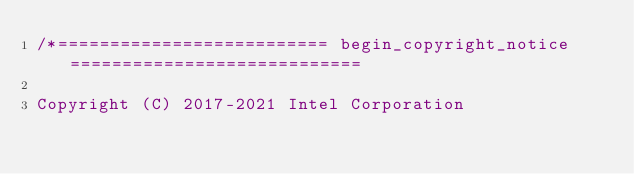Convert code to text. <code><loc_0><loc_0><loc_500><loc_500><_C++_>/*========================== begin_copyright_notice ============================

Copyright (C) 2017-2021 Intel Corporation
</code> 